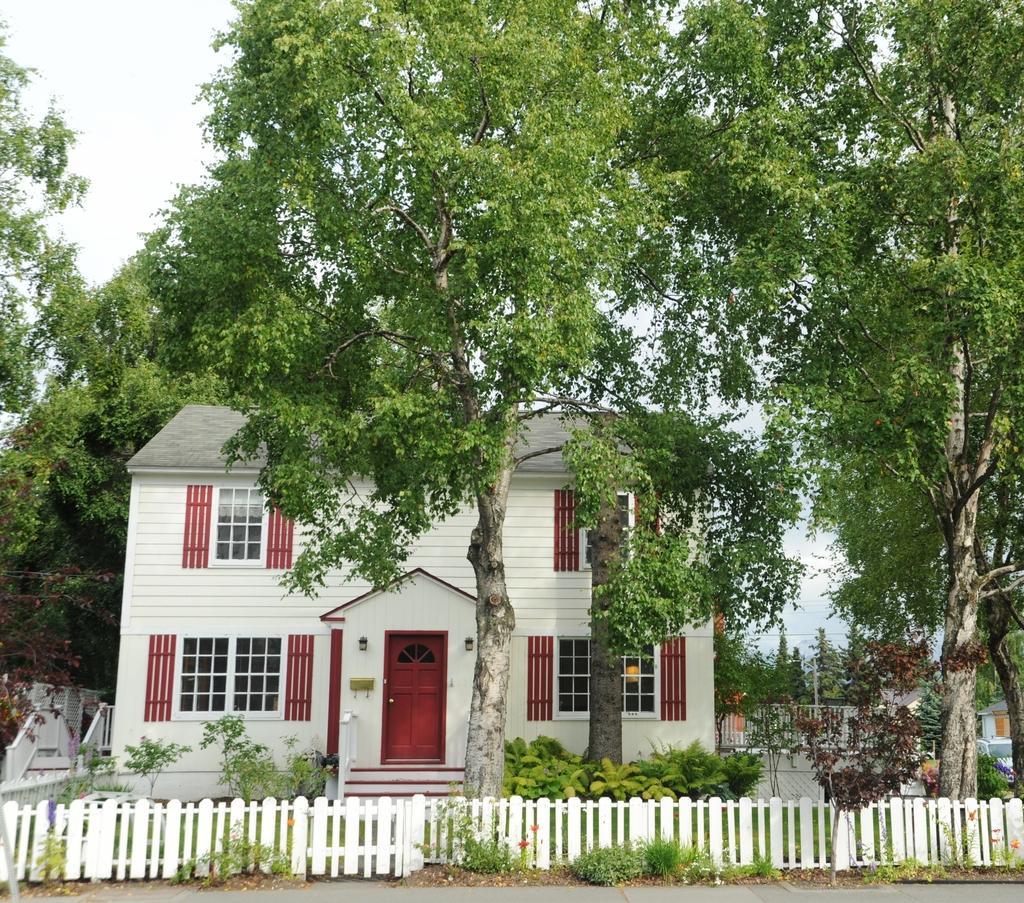Please provide a concise description of this image. In this image we can see a building with windows and door. Also there are steps. Near to the building there are trees and plants. Also there is fencing. In the background there is sky. 